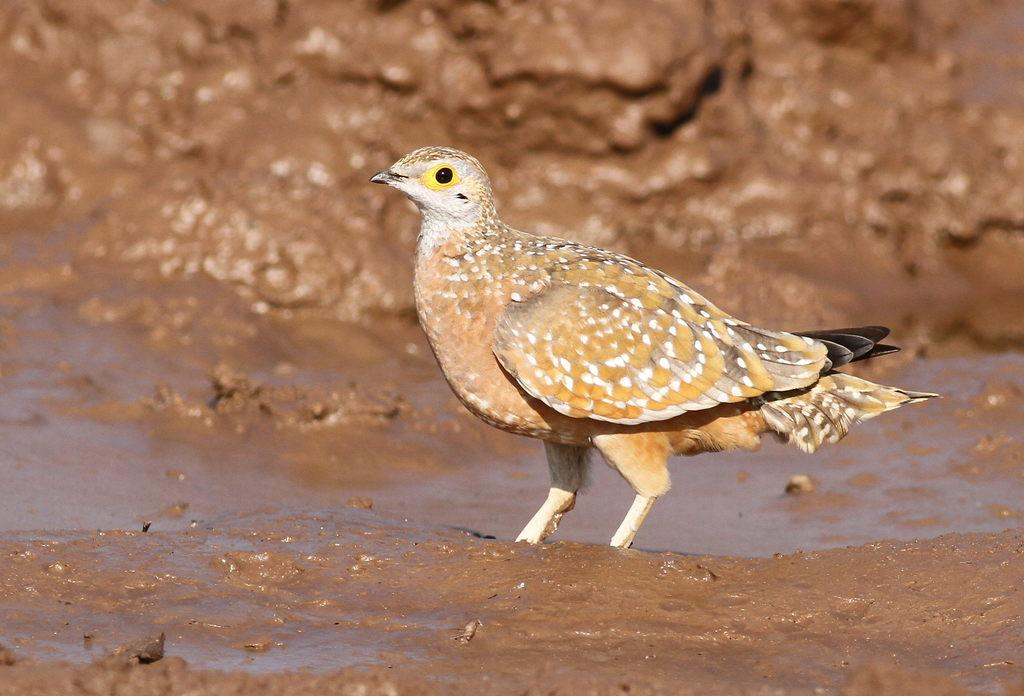What type of animal can be seen in the image? There is a bird in the image. Where is the bird located? The bird is on the ground. What can be seen in the background of the image? There is mud visible in the background of the image. How would you describe the quality of the background in the image? The background of the image is blurred. What type of mist can be seen surrounding the bird in the image? There is no mist present in the image; the bird is on the ground with a blurred background. 